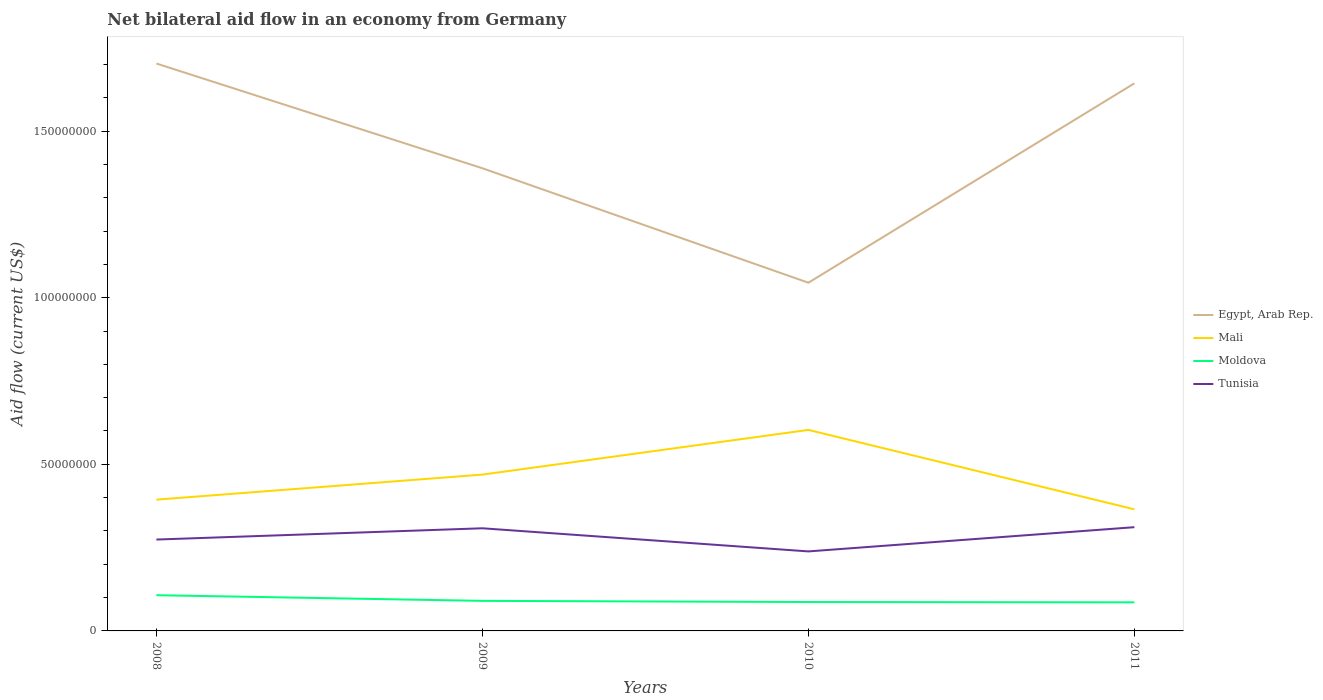Does the line corresponding to Tunisia intersect with the line corresponding to Mali?
Provide a succinct answer. No. Is the number of lines equal to the number of legend labels?
Give a very brief answer. Yes. Across all years, what is the maximum net bilateral aid flow in Moldova?
Provide a short and direct response. 8.58e+06. In which year was the net bilateral aid flow in Egypt, Arab Rep. maximum?
Ensure brevity in your answer.  2010. What is the total net bilateral aid flow in Tunisia in the graph?
Your answer should be very brief. -3.30e+05. What is the difference between the highest and the second highest net bilateral aid flow in Tunisia?
Provide a succinct answer. 7.27e+06. How many lines are there?
Make the answer very short. 4. How many years are there in the graph?
Keep it short and to the point. 4. What is the difference between two consecutive major ticks on the Y-axis?
Offer a very short reply. 5.00e+07. How are the legend labels stacked?
Offer a terse response. Vertical. What is the title of the graph?
Keep it short and to the point. Net bilateral aid flow in an economy from Germany. What is the label or title of the X-axis?
Make the answer very short. Years. What is the label or title of the Y-axis?
Your response must be concise. Aid flow (current US$). What is the Aid flow (current US$) of Egypt, Arab Rep. in 2008?
Your response must be concise. 1.70e+08. What is the Aid flow (current US$) in Mali in 2008?
Offer a terse response. 3.94e+07. What is the Aid flow (current US$) in Moldova in 2008?
Give a very brief answer. 1.07e+07. What is the Aid flow (current US$) in Tunisia in 2008?
Your answer should be compact. 2.74e+07. What is the Aid flow (current US$) of Egypt, Arab Rep. in 2009?
Your response must be concise. 1.39e+08. What is the Aid flow (current US$) in Mali in 2009?
Provide a short and direct response. 4.69e+07. What is the Aid flow (current US$) in Moldova in 2009?
Ensure brevity in your answer.  9.02e+06. What is the Aid flow (current US$) in Tunisia in 2009?
Keep it short and to the point. 3.08e+07. What is the Aid flow (current US$) in Egypt, Arab Rep. in 2010?
Provide a short and direct response. 1.04e+08. What is the Aid flow (current US$) in Mali in 2010?
Offer a terse response. 6.03e+07. What is the Aid flow (current US$) of Moldova in 2010?
Make the answer very short. 8.67e+06. What is the Aid flow (current US$) in Tunisia in 2010?
Your response must be concise. 2.39e+07. What is the Aid flow (current US$) in Egypt, Arab Rep. in 2011?
Make the answer very short. 1.64e+08. What is the Aid flow (current US$) in Mali in 2011?
Offer a very short reply. 3.65e+07. What is the Aid flow (current US$) of Moldova in 2011?
Your response must be concise. 8.58e+06. What is the Aid flow (current US$) of Tunisia in 2011?
Ensure brevity in your answer.  3.11e+07. Across all years, what is the maximum Aid flow (current US$) in Egypt, Arab Rep.?
Keep it short and to the point. 1.70e+08. Across all years, what is the maximum Aid flow (current US$) in Mali?
Keep it short and to the point. 6.03e+07. Across all years, what is the maximum Aid flow (current US$) in Moldova?
Ensure brevity in your answer.  1.07e+07. Across all years, what is the maximum Aid flow (current US$) in Tunisia?
Provide a succinct answer. 3.11e+07. Across all years, what is the minimum Aid flow (current US$) of Egypt, Arab Rep.?
Offer a terse response. 1.04e+08. Across all years, what is the minimum Aid flow (current US$) of Mali?
Provide a short and direct response. 3.65e+07. Across all years, what is the minimum Aid flow (current US$) in Moldova?
Provide a short and direct response. 8.58e+06. Across all years, what is the minimum Aid flow (current US$) in Tunisia?
Give a very brief answer. 2.39e+07. What is the total Aid flow (current US$) in Egypt, Arab Rep. in the graph?
Offer a terse response. 5.78e+08. What is the total Aid flow (current US$) of Mali in the graph?
Ensure brevity in your answer.  1.83e+08. What is the total Aid flow (current US$) in Moldova in the graph?
Make the answer very short. 3.70e+07. What is the total Aid flow (current US$) of Tunisia in the graph?
Your answer should be very brief. 1.13e+08. What is the difference between the Aid flow (current US$) in Egypt, Arab Rep. in 2008 and that in 2009?
Offer a very short reply. 3.14e+07. What is the difference between the Aid flow (current US$) in Mali in 2008 and that in 2009?
Make the answer very short. -7.52e+06. What is the difference between the Aid flow (current US$) of Moldova in 2008 and that in 2009?
Offer a very short reply. 1.70e+06. What is the difference between the Aid flow (current US$) in Tunisia in 2008 and that in 2009?
Make the answer very short. -3.38e+06. What is the difference between the Aid flow (current US$) of Egypt, Arab Rep. in 2008 and that in 2010?
Provide a succinct answer. 6.58e+07. What is the difference between the Aid flow (current US$) in Mali in 2008 and that in 2010?
Your answer should be very brief. -2.09e+07. What is the difference between the Aid flow (current US$) of Moldova in 2008 and that in 2010?
Your response must be concise. 2.05e+06. What is the difference between the Aid flow (current US$) in Tunisia in 2008 and that in 2010?
Your answer should be compact. 3.56e+06. What is the difference between the Aid flow (current US$) in Egypt, Arab Rep. in 2008 and that in 2011?
Offer a very short reply. 5.94e+06. What is the difference between the Aid flow (current US$) in Mali in 2008 and that in 2011?
Ensure brevity in your answer.  2.90e+06. What is the difference between the Aid flow (current US$) in Moldova in 2008 and that in 2011?
Ensure brevity in your answer.  2.14e+06. What is the difference between the Aid flow (current US$) in Tunisia in 2008 and that in 2011?
Ensure brevity in your answer.  -3.71e+06. What is the difference between the Aid flow (current US$) in Egypt, Arab Rep. in 2009 and that in 2010?
Ensure brevity in your answer.  3.44e+07. What is the difference between the Aid flow (current US$) of Mali in 2009 and that in 2010?
Give a very brief answer. -1.34e+07. What is the difference between the Aid flow (current US$) in Tunisia in 2009 and that in 2010?
Offer a very short reply. 6.94e+06. What is the difference between the Aid flow (current US$) of Egypt, Arab Rep. in 2009 and that in 2011?
Keep it short and to the point. -2.55e+07. What is the difference between the Aid flow (current US$) of Mali in 2009 and that in 2011?
Provide a succinct answer. 1.04e+07. What is the difference between the Aid flow (current US$) in Tunisia in 2009 and that in 2011?
Offer a very short reply. -3.30e+05. What is the difference between the Aid flow (current US$) of Egypt, Arab Rep. in 2010 and that in 2011?
Your response must be concise. -5.98e+07. What is the difference between the Aid flow (current US$) in Mali in 2010 and that in 2011?
Give a very brief answer. 2.38e+07. What is the difference between the Aid flow (current US$) of Tunisia in 2010 and that in 2011?
Give a very brief answer. -7.27e+06. What is the difference between the Aid flow (current US$) of Egypt, Arab Rep. in 2008 and the Aid flow (current US$) of Mali in 2009?
Your answer should be compact. 1.23e+08. What is the difference between the Aid flow (current US$) of Egypt, Arab Rep. in 2008 and the Aid flow (current US$) of Moldova in 2009?
Provide a short and direct response. 1.61e+08. What is the difference between the Aid flow (current US$) in Egypt, Arab Rep. in 2008 and the Aid flow (current US$) in Tunisia in 2009?
Your answer should be compact. 1.39e+08. What is the difference between the Aid flow (current US$) in Mali in 2008 and the Aid flow (current US$) in Moldova in 2009?
Your answer should be compact. 3.04e+07. What is the difference between the Aid flow (current US$) in Mali in 2008 and the Aid flow (current US$) in Tunisia in 2009?
Your response must be concise. 8.59e+06. What is the difference between the Aid flow (current US$) in Moldova in 2008 and the Aid flow (current US$) in Tunisia in 2009?
Your response must be concise. -2.01e+07. What is the difference between the Aid flow (current US$) of Egypt, Arab Rep. in 2008 and the Aid flow (current US$) of Mali in 2010?
Offer a terse response. 1.10e+08. What is the difference between the Aid flow (current US$) in Egypt, Arab Rep. in 2008 and the Aid flow (current US$) in Moldova in 2010?
Offer a terse response. 1.62e+08. What is the difference between the Aid flow (current US$) in Egypt, Arab Rep. in 2008 and the Aid flow (current US$) in Tunisia in 2010?
Ensure brevity in your answer.  1.46e+08. What is the difference between the Aid flow (current US$) of Mali in 2008 and the Aid flow (current US$) of Moldova in 2010?
Ensure brevity in your answer.  3.07e+07. What is the difference between the Aid flow (current US$) in Mali in 2008 and the Aid flow (current US$) in Tunisia in 2010?
Provide a succinct answer. 1.55e+07. What is the difference between the Aid flow (current US$) of Moldova in 2008 and the Aid flow (current US$) of Tunisia in 2010?
Give a very brief answer. -1.31e+07. What is the difference between the Aid flow (current US$) of Egypt, Arab Rep. in 2008 and the Aid flow (current US$) of Mali in 2011?
Your response must be concise. 1.34e+08. What is the difference between the Aid flow (current US$) in Egypt, Arab Rep. in 2008 and the Aid flow (current US$) in Moldova in 2011?
Provide a short and direct response. 1.62e+08. What is the difference between the Aid flow (current US$) of Egypt, Arab Rep. in 2008 and the Aid flow (current US$) of Tunisia in 2011?
Your answer should be compact. 1.39e+08. What is the difference between the Aid flow (current US$) in Mali in 2008 and the Aid flow (current US$) in Moldova in 2011?
Your answer should be compact. 3.08e+07. What is the difference between the Aid flow (current US$) in Mali in 2008 and the Aid flow (current US$) in Tunisia in 2011?
Offer a very short reply. 8.26e+06. What is the difference between the Aid flow (current US$) of Moldova in 2008 and the Aid flow (current US$) of Tunisia in 2011?
Offer a terse response. -2.04e+07. What is the difference between the Aid flow (current US$) of Egypt, Arab Rep. in 2009 and the Aid flow (current US$) of Mali in 2010?
Ensure brevity in your answer.  7.85e+07. What is the difference between the Aid flow (current US$) of Egypt, Arab Rep. in 2009 and the Aid flow (current US$) of Moldova in 2010?
Your answer should be compact. 1.30e+08. What is the difference between the Aid flow (current US$) of Egypt, Arab Rep. in 2009 and the Aid flow (current US$) of Tunisia in 2010?
Your answer should be compact. 1.15e+08. What is the difference between the Aid flow (current US$) in Mali in 2009 and the Aid flow (current US$) in Moldova in 2010?
Provide a short and direct response. 3.82e+07. What is the difference between the Aid flow (current US$) of Mali in 2009 and the Aid flow (current US$) of Tunisia in 2010?
Offer a very short reply. 2.30e+07. What is the difference between the Aid flow (current US$) in Moldova in 2009 and the Aid flow (current US$) in Tunisia in 2010?
Give a very brief answer. -1.48e+07. What is the difference between the Aid flow (current US$) in Egypt, Arab Rep. in 2009 and the Aid flow (current US$) in Mali in 2011?
Your response must be concise. 1.02e+08. What is the difference between the Aid flow (current US$) in Egypt, Arab Rep. in 2009 and the Aid flow (current US$) in Moldova in 2011?
Provide a succinct answer. 1.30e+08. What is the difference between the Aid flow (current US$) of Egypt, Arab Rep. in 2009 and the Aid flow (current US$) of Tunisia in 2011?
Provide a succinct answer. 1.08e+08. What is the difference between the Aid flow (current US$) in Mali in 2009 and the Aid flow (current US$) in Moldova in 2011?
Your response must be concise. 3.83e+07. What is the difference between the Aid flow (current US$) of Mali in 2009 and the Aid flow (current US$) of Tunisia in 2011?
Give a very brief answer. 1.58e+07. What is the difference between the Aid flow (current US$) in Moldova in 2009 and the Aid flow (current US$) in Tunisia in 2011?
Keep it short and to the point. -2.21e+07. What is the difference between the Aid flow (current US$) in Egypt, Arab Rep. in 2010 and the Aid flow (current US$) in Mali in 2011?
Make the answer very short. 6.80e+07. What is the difference between the Aid flow (current US$) of Egypt, Arab Rep. in 2010 and the Aid flow (current US$) of Moldova in 2011?
Offer a terse response. 9.59e+07. What is the difference between the Aid flow (current US$) of Egypt, Arab Rep. in 2010 and the Aid flow (current US$) of Tunisia in 2011?
Provide a succinct answer. 7.34e+07. What is the difference between the Aid flow (current US$) in Mali in 2010 and the Aid flow (current US$) in Moldova in 2011?
Your answer should be very brief. 5.17e+07. What is the difference between the Aid flow (current US$) in Mali in 2010 and the Aid flow (current US$) in Tunisia in 2011?
Keep it short and to the point. 2.92e+07. What is the difference between the Aid flow (current US$) of Moldova in 2010 and the Aid flow (current US$) of Tunisia in 2011?
Provide a succinct answer. -2.25e+07. What is the average Aid flow (current US$) in Egypt, Arab Rep. per year?
Your answer should be compact. 1.44e+08. What is the average Aid flow (current US$) in Mali per year?
Ensure brevity in your answer.  4.58e+07. What is the average Aid flow (current US$) in Moldova per year?
Give a very brief answer. 9.25e+06. What is the average Aid flow (current US$) of Tunisia per year?
Offer a terse response. 2.83e+07. In the year 2008, what is the difference between the Aid flow (current US$) of Egypt, Arab Rep. and Aid flow (current US$) of Mali?
Offer a terse response. 1.31e+08. In the year 2008, what is the difference between the Aid flow (current US$) of Egypt, Arab Rep. and Aid flow (current US$) of Moldova?
Ensure brevity in your answer.  1.60e+08. In the year 2008, what is the difference between the Aid flow (current US$) of Egypt, Arab Rep. and Aid flow (current US$) of Tunisia?
Offer a very short reply. 1.43e+08. In the year 2008, what is the difference between the Aid flow (current US$) in Mali and Aid flow (current US$) in Moldova?
Make the answer very short. 2.87e+07. In the year 2008, what is the difference between the Aid flow (current US$) in Mali and Aid flow (current US$) in Tunisia?
Ensure brevity in your answer.  1.20e+07. In the year 2008, what is the difference between the Aid flow (current US$) of Moldova and Aid flow (current US$) of Tunisia?
Provide a short and direct response. -1.67e+07. In the year 2009, what is the difference between the Aid flow (current US$) in Egypt, Arab Rep. and Aid flow (current US$) in Mali?
Provide a short and direct response. 9.19e+07. In the year 2009, what is the difference between the Aid flow (current US$) in Egypt, Arab Rep. and Aid flow (current US$) in Moldova?
Offer a terse response. 1.30e+08. In the year 2009, what is the difference between the Aid flow (current US$) in Egypt, Arab Rep. and Aid flow (current US$) in Tunisia?
Provide a short and direct response. 1.08e+08. In the year 2009, what is the difference between the Aid flow (current US$) in Mali and Aid flow (current US$) in Moldova?
Offer a terse response. 3.79e+07. In the year 2009, what is the difference between the Aid flow (current US$) in Mali and Aid flow (current US$) in Tunisia?
Your response must be concise. 1.61e+07. In the year 2009, what is the difference between the Aid flow (current US$) of Moldova and Aid flow (current US$) of Tunisia?
Ensure brevity in your answer.  -2.18e+07. In the year 2010, what is the difference between the Aid flow (current US$) in Egypt, Arab Rep. and Aid flow (current US$) in Mali?
Your response must be concise. 4.42e+07. In the year 2010, what is the difference between the Aid flow (current US$) of Egypt, Arab Rep. and Aid flow (current US$) of Moldova?
Provide a succinct answer. 9.58e+07. In the year 2010, what is the difference between the Aid flow (current US$) in Egypt, Arab Rep. and Aid flow (current US$) in Tunisia?
Provide a succinct answer. 8.06e+07. In the year 2010, what is the difference between the Aid flow (current US$) in Mali and Aid flow (current US$) in Moldova?
Make the answer very short. 5.16e+07. In the year 2010, what is the difference between the Aid flow (current US$) in Mali and Aid flow (current US$) in Tunisia?
Make the answer very short. 3.65e+07. In the year 2010, what is the difference between the Aid flow (current US$) in Moldova and Aid flow (current US$) in Tunisia?
Make the answer very short. -1.52e+07. In the year 2011, what is the difference between the Aid flow (current US$) in Egypt, Arab Rep. and Aid flow (current US$) in Mali?
Make the answer very short. 1.28e+08. In the year 2011, what is the difference between the Aid flow (current US$) in Egypt, Arab Rep. and Aid flow (current US$) in Moldova?
Give a very brief answer. 1.56e+08. In the year 2011, what is the difference between the Aid flow (current US$) in Egypt, Arab Rep. and Aid flow (current US$) in Tunisia?
Keep it short and to the point. 1.33e+08. In the year 2011, what is the difference between the Aid flow (current US$) of Mali and Aid flow (current US$) of Moldova?
Offer a terse response. 2.79e+07. In the year 2011, what is the difference between the Aid flow (current US$) in Mali and Aid flow (current US$) in Tunisia?
Your response must be concise. 5.36e+06. In the year 2011, what is the difference between the Aid flow (current US$) in Moldova and Aid flow (current US$) in Tunisia?
Offer a very short reply. -2.26e+07. What is the ratio of the Aid flow (current US$) in Egypt, Arab Rep. in 2008 to that in 2009?
Your response must be concise. 1.23. What is the ratio of the Aid flow (current US$) in Mali in 2008 to that in 2009?
Keep it short and to the point. 0.84. What is the ratio of the Aid flow (current US$) in Moldova in 2008 to that in 2009?
Ensure brevity in your answer.  1.19. What is the ratio of the Aid flow (current US$) of Tunisia in 2008 to that in 2009?
Keep it short and to the point. 0.89. What is the ratio of the Aid flow (current US$) of Egypt, Arab Rep. in 2008 to that in 2010?
Give a very brief answer. 1.63. What is the ratio of the Aid flow (current US$) in Mali in 2008 to that in 2010?
Give a very brief answer. 0.65. What is the ratio of the Aid flow (current US$) of Moldova in 2008 to that in 2010?
Provide a short and direct response. 1.24. What is the ratio of the Aid flow (current US$) in Tunisia in 2008 to that in 2010?
Give a very brief answer. 1.15. What is the ratio of the Aid flow (current US$) of Egypt, Arab Rep. in 2008 to that in 2011?
Offer a terse response. 1.04. What is the ratio of the Aid flow (current US$) in Mali in 2008 to that in 2011?
Keep it short and to the point. 1.08. What is the ratio of the Aid flow (current US$) of Moldova in 2008 to that in 2011?
Your answer should be very brief. 1.25. What is the ratio of the Aid flow (current US$) of Tunisia in 2008 to that in 2011?
Ensure brevity in your answer.  0.88. What is the ratio of the Aid flow (current US$) in Egypt, Arab Rep. in 2009 to that in 2010?
Offer a very short reply. 1.33. What is the ratio of the Aid flow (current US$) of Mali in 2009 to that in 2010?
Ensure brevity in your answer.  0.78. What is the ratio of the Aid flow (current US$) in Moldova in 2009 to that in 2010?
Keep it short and to the point. 1.04. What is the ratio of the Aid flow (current US$) in Tunisia in 2009 to that in 2010?
Provide a succinct answer. 1.29. What is the ratio of the Aid flow (current US$) of Egypt, Arab Rep. in 2009 to that in 2011?
Give a very brief answer. 0.84. What is the ratio of the Aid flow (current US$) of Mali in 2009 to that in 2011?
Ensure brevity in your answer.  1.29. What is the ratio of the Aid flow (current US$) in Moldova in 2009 to that in 2011?
Offer a very short reply. 1.05. What is the ratio of the Aid flow (current US$) of Egypt, Arab Rep. in 2010 to that in 2011?
Offer a very short reply. 0.64. What is the ratio of the Aid flow (current US$) in Mali in 2010 to that in 2011?
Your answer should be very brief. 1.65. What is the ratio of the Aid flow (current US$) in Moldova in 2010 to that in 2011?
Offer a terse response. 1.01. What is the ratio of the Aid flow (current US$) of Tunisia in 2010 to that in 2011?
Give a very brief answer. 0.77. What is the difference between the highest and the second highest Aid flow (current US$) in Egypt, Arab Rep.?
Your response must be concise. 5.94e+06. What is the difference between the highest and the second highest Aid flow (current US$) in Mali?
Make the answer very short. 1.34e+07. What is the difference between the highest and the second highest Aid flow (current US$) in Moldova?
Your response must be concise. 1.70e+06. What is the difference between the highest and the second highest Aid flow (current US$) in Tunisia?
Give a very brief answer. 3.30e+05. What is the difference between the highest and the lowest Aid flow (current US$) in Egypt, Arab Rep.?
Provide a succinct answer. 6.58e+07. What is the difference between the highest and the lowest Aid flow (current US$) in Mali?
Offer a terse response. 2.38e+07. What is the difference between the highest and the lowest Aid flow (current US$) in Moldova?
Your response must be concise. 2.14e+06. What is the difference between the highest and the lowest Aid flow (current US$) of Tunisia?
Provide a succinct answer. 7.27e+06. 